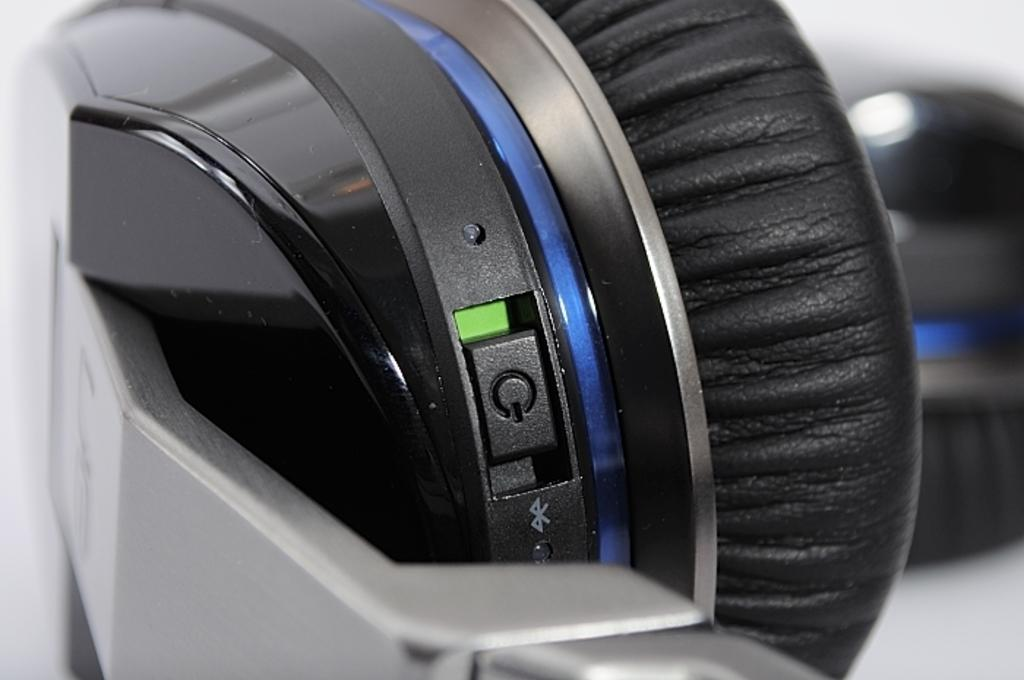What type of device is partially visible in the image? There is a part of a headset in the image. What is a key feature of the headset? The headset has a speaker. What is the color of the speaker? The speaker is black in color. How can the headset be turned on or off? There is a power button on the headset. What color is the light on the power button? The power button has a green color light. Can you see any steam coming from the headset in the image? There is no steam present in the image; it features a part of a headset with a speaker, power button, and green light. 